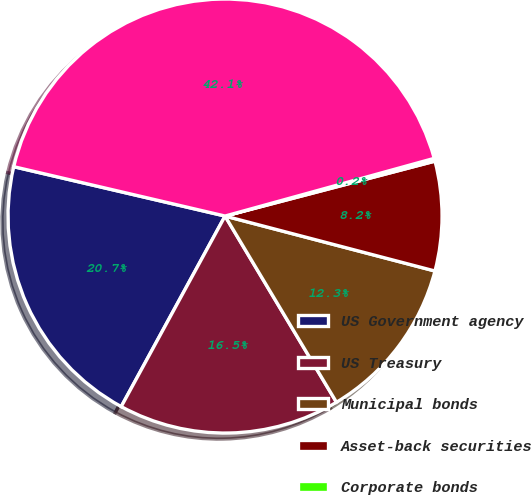Convert chart. <chart><loc_0><loc_0><loc_500><loc_500><pie_chart><fcel>US Government agency<fcel>US Treasury<fcel>Municipal bonds<fcel>Asset-back securities<fcel>Corporate bonds<fcel>Total<nl><fcel>20.71%<fcel>16.52%<fcel>12.34%<fcel>8.15%<fcel>0.21%<fcel>42.06%<nl></chart> 